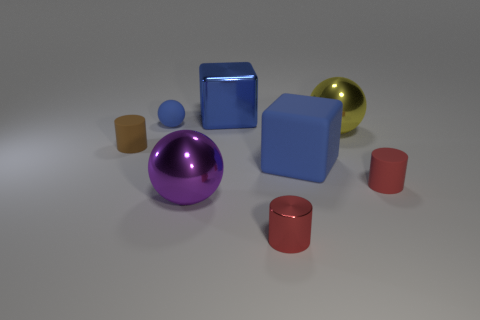Add 1 small balls. How many objects exist? 9 Subtract all blocks. How many objects are left? 6 Subtract all tiny blue objects. Subtract all big things. How many objects are left? 3 Add 8 yellow spheres. How many yellow spheres are left? 9 Add 7 balls. How many balls exist? 10 Subtract 0 green balls. How many objects are left? 8 